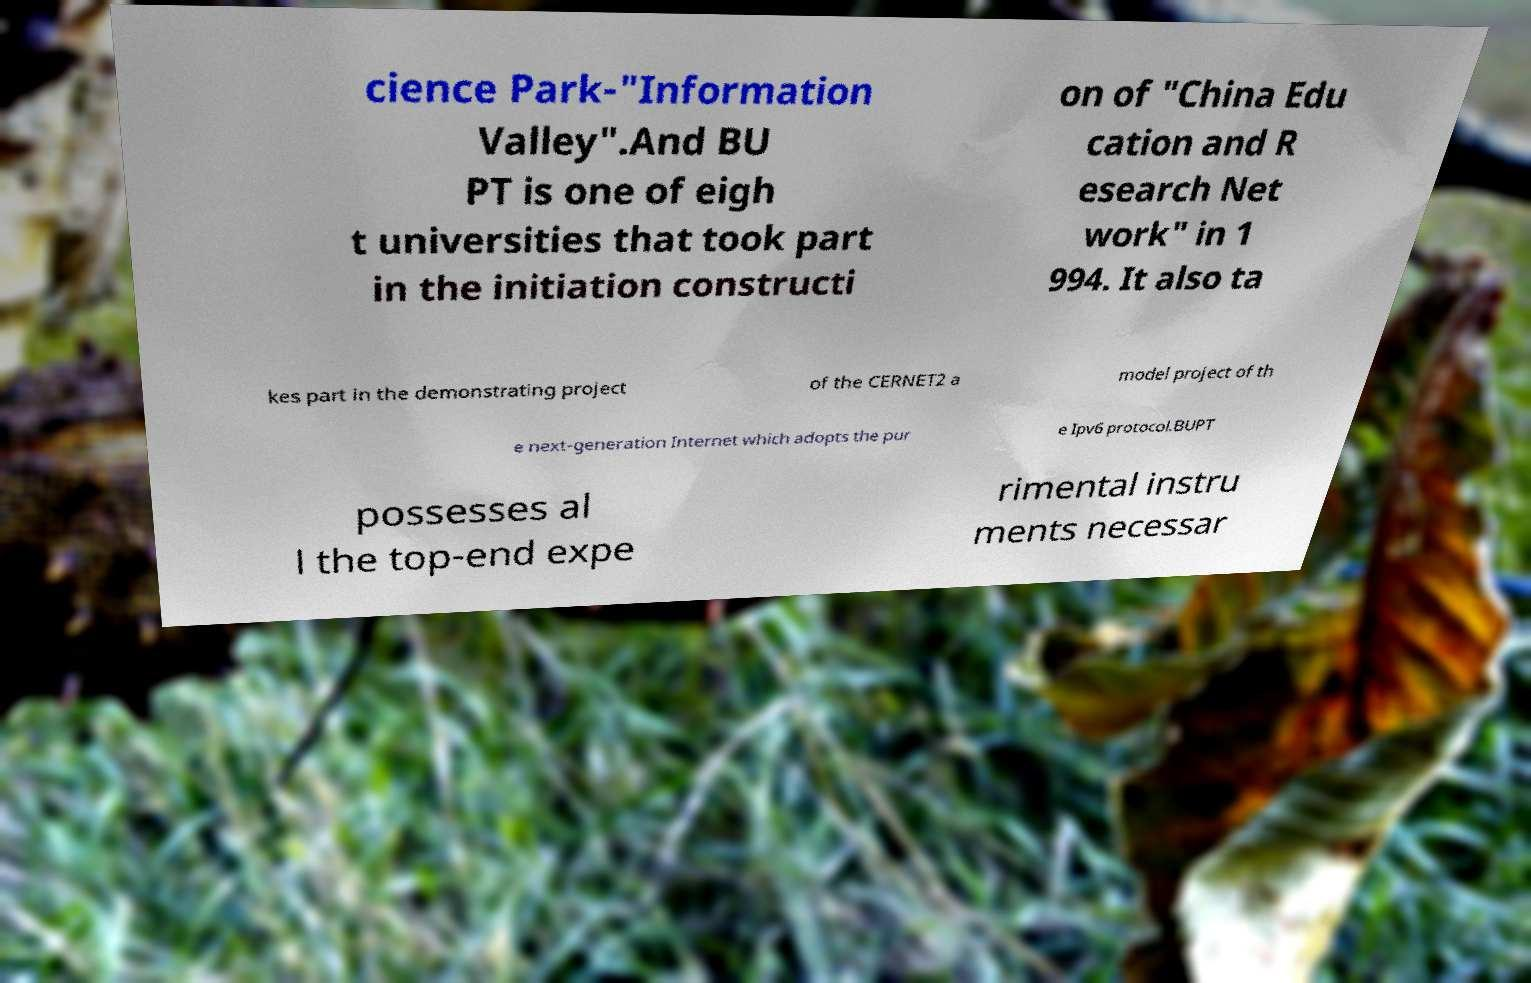Could you assist in decoding the text presented in this image and type it out clearly? cience Park-"Information Valley".And BU PT is one of eigh t universities that took part in the initiation constructi on of "China Edu cation and R esearch Net work" in 1 994. It also ta kes part in the demonstrating project of the CERNET2 a model project of th e next-generation Internet which adopts the pur e Ipv6 protocol.BUPT possesses al l the top-end expe rimental instru ments necessar 